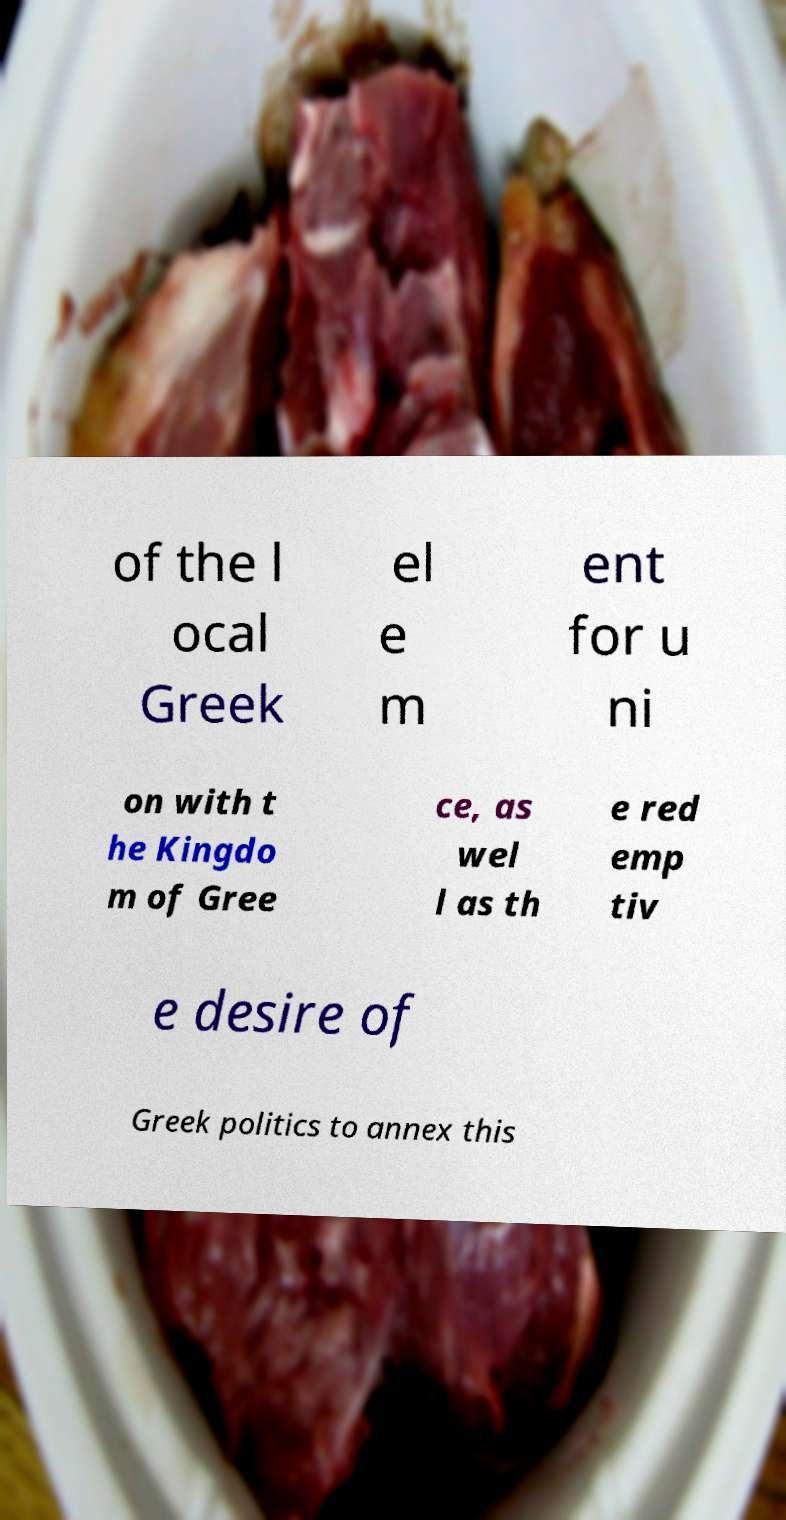Could you assist in decoding the text presented in this image and type it out clearly? of the l ocal Greek el e m ent for u ni on with t he Kingdo m of Gree ce, as wel l as th e red emp tiv e desire of Greek politics to annex this 